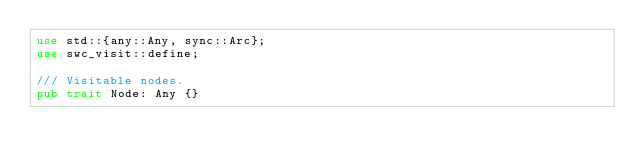Convert code to text. <code><loc_0><loc_0><loc_500><loc_500><_Rust_>use std::{any::Any, sync::Arc};
use swc_visit::define;

/// Visitable nodes.
pub trait Node: Any {}
</code> 